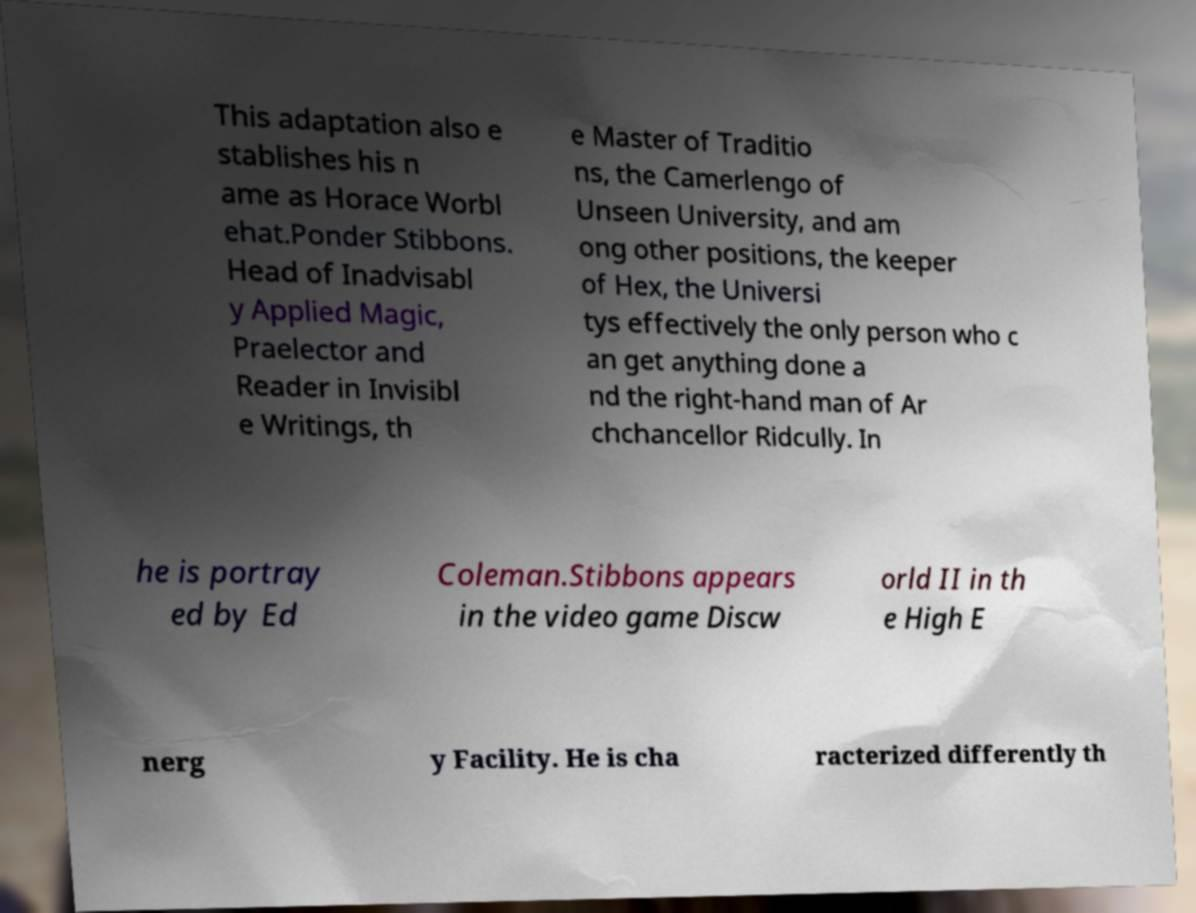What messages or text are displayed in this image? I need them in a readable, typed format. This adaptation also e stablishes his n ame as Horace Worbl ehat.Ponder Stibbons. Head of Inadvisabl y Applied Magic, Praelector and Reader in Invisibl e Writings, th e Master of Traditio ns, the Camerlengo of Unseen University, and am ong other positions, the keeper of Hex, the Universi tys effectively the only person who c an get anything done a nd the right-hand man of Ar chchancellor Ridcully. In he is portray ed by Ed Coleman.Stibbons appears in the video game Discw orld II in th e High E nerg y Facility. He is cha racterized differently th 